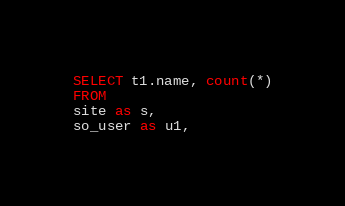Convert code to text. <code><loc_0><loc_0><loc_500><loc_500><_SQL_>SELECT t1.name, count(*)
FROM
site as s,
so_user as u1,</code> 